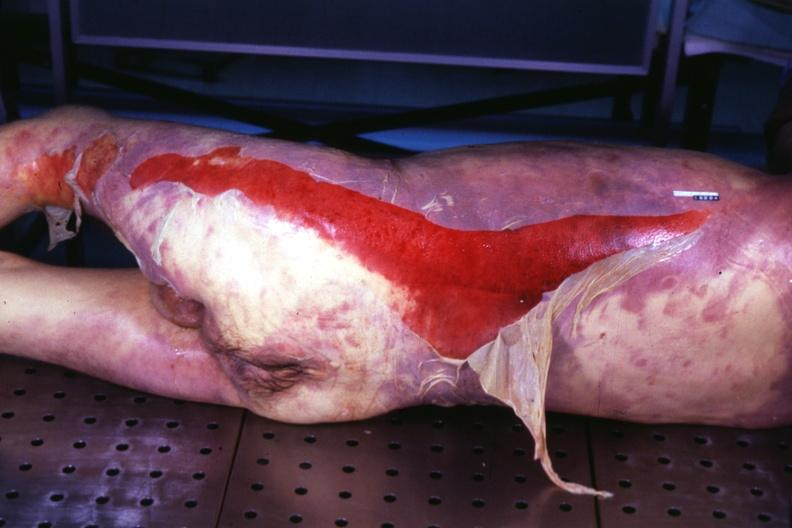does underdevelopment show body with extensive ecchymoses and desquamation?
Answer the question using a single word or phrase. No 